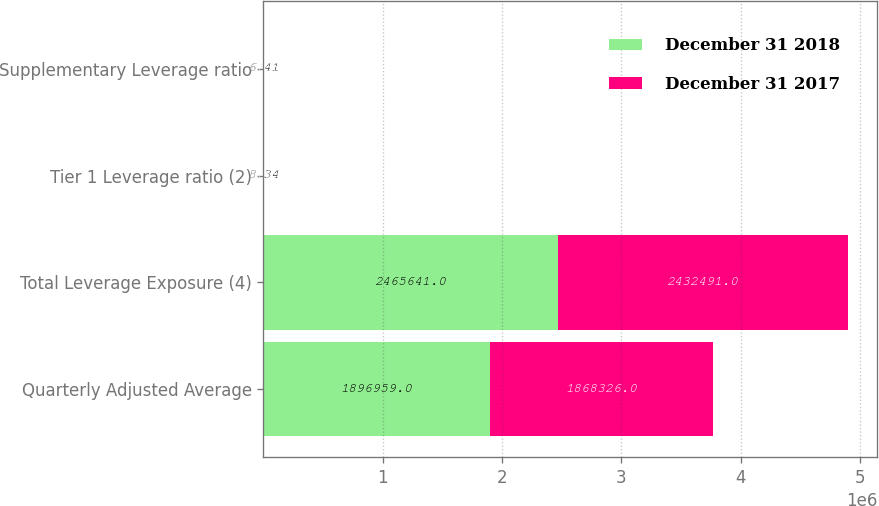<chart> <loc_0><loc_0><loc_500><loc_500><stacked_bar_chart><ecel><fcel>Quarterly Adjusted Average<fcel>Total Leverage Exposure (4)<fcel>Tier 1 Leverage ratio (2)<fcel>Supplementary Leverage ratio<nl><fcel>December 31 2018<fcel>1.89696e+06<fcel>2.46564e+06<fcel>8.34<fcel>6.41<nl><fcel>December 31 2017<fcel>1.86833e+06<fcel>2.43249e+06<fcel>8.69<fcel>6.68<nl></chart> 